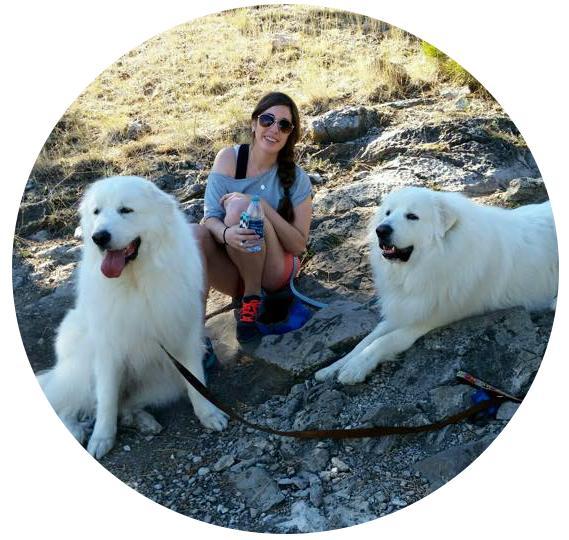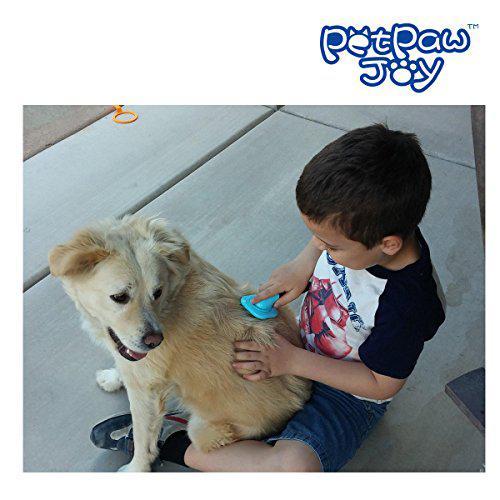The first image is the image on the left, the second image is the image on the right. Analyze the images presented: Is the assertion "A girl wearing a blue shirt and sunglasses is sitting in between 2 large white dogs." valid? Answer yes or no. Yes. 